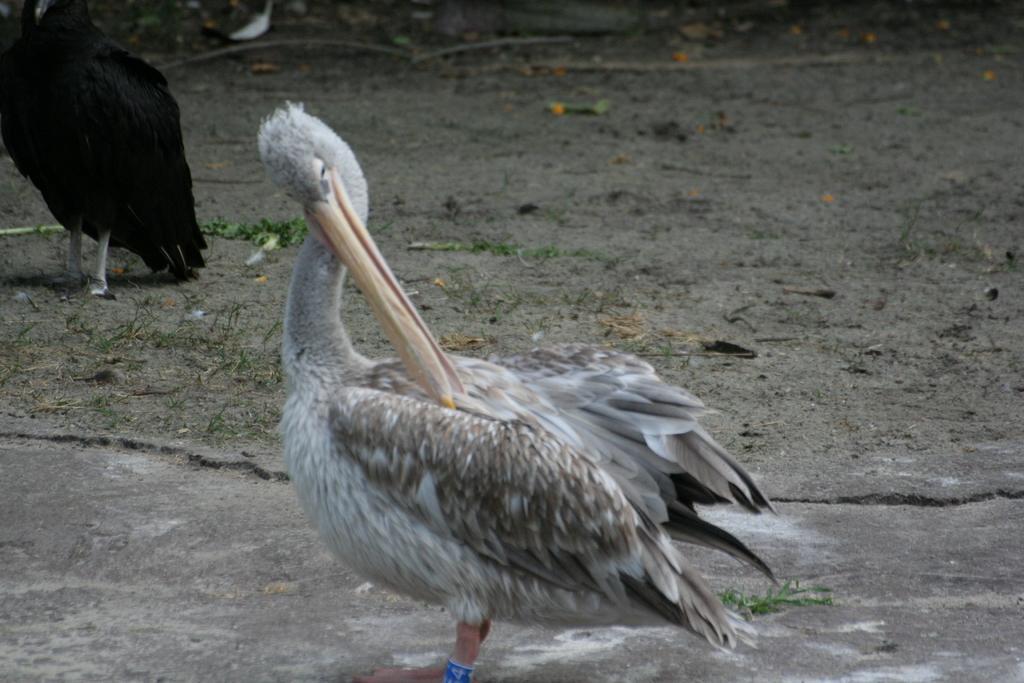How would you summarize this image in a sentence or two? In this image we can see some birds on the ground. We can also see some leaves on the ground. 